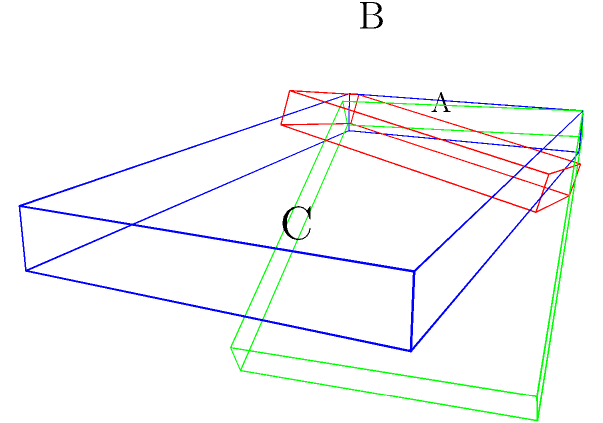An adjustable hospital bed has a backrest that can be elevated up to 30° and a leg support that can be lowered up to 15°. If the bed's total length is 6 feet when flat, what is the horizontal distance between points A and C when both the backrest and leg support are at their maximum angles? Let's approach this step-by-step:

1) First, we need to break down the bed into three sections:
   - The fixed middle section
   - The adjustable backrest
   - The adjustable leg support

2) Let's assume the backrest is 4 feet long and the leg support is 2 feet long when flat.

3) For the backrest (section AB):
   - When elevated 30°, its horizontal projection can be calculated using cosine:
   - Horizontal length of AB = 4 * cos(30°) = 4 * $\frac{\sqrt{3}}{2}$ ≈ 3.464 feet

4) For the leg support (section BC):
   - When lowered 15°, its horizontal projection can be calculated using cosine:
   - Horizontal length of BC = 2 * cos(15°) = 2 * $\frac{\sqrt{6}+\sqrt{2}}{4}$ ≈ 1.932 feet

5) The total horizontal distance between A and C is the sum of these two projections:
   AC = 3.464 + 1.932 = 5.396 feet

6) Rounding to two decimal places, we get 5.40 feet.
Answer: 5.40 feet 